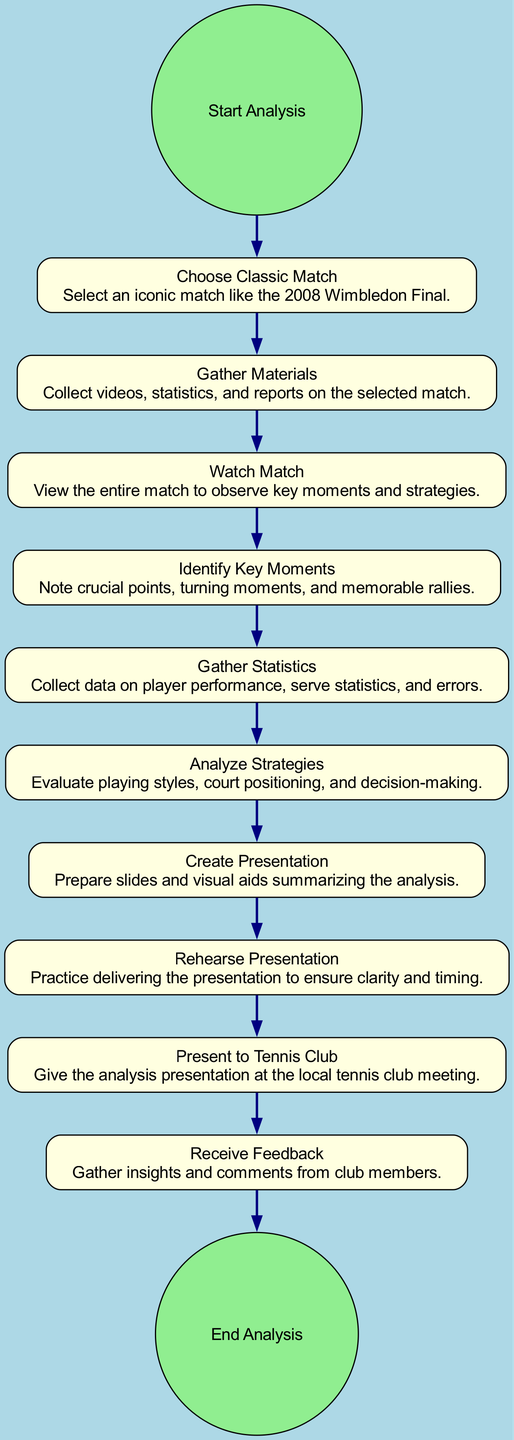what is the first activity in the analysis process? The first activity listed in the diagram is "Start Analysis." This is indicated as the first node in the sequence of activities, denoting the beginning of the process.
Answer: Start Analysis how many total activities are listed in the diagram? The diagram includes a total of 12 activities, which includes the start and end points as well as all intermediate activities.
Answer: 12 which activity follows "Watch Match"? The activity that follows "Watch Match" is "Identify Key Moments." This is represented by a direct transition from the "Watch Match" node to the "Identify Key Moments" node in the diagram.
Answer: Identify Key Moments what are the final two activities before reaching the end of the analysis? The final two activities before the end are "Present to Tennis Club" and "Receive Feedback." These activities represent the concluding steps of the analysis process.
Answer: Present to Tennis Club, Receive Feedback what is the main purpose of the "Gather Materials" activity? The purpose of the "Gather Materials" activity is to collect videos, statistics, and reports on the selected match. This is specified in the description associated with this activity in the diagram.
Answer: Collect videos, statistics, and reports which activity requires the analysis of player performance? The activity that requires the analysis of player performance is "Gather Statistics." This activity focuses on collecting various data related to player performance, which is crucial for the analysis process.
Answer: Gather Statistics how are the activities "Create Presentation" and "Rehearse Presentation" related in the diagram? The activities "Create Presentation" and "Rehearse Presentation" are sequentially connected, with "Create Presentation" directly leading to "Rehearse Presentation." This indicates the logical flow of preparing and practicing for the presentation.
Answer: Sequentially connected how many transitions are there in the diagram? There are 11 transitions in the diagram, each representing a distinct movement from one activity to the next as the analysis process unfolds.
Answer: 11 